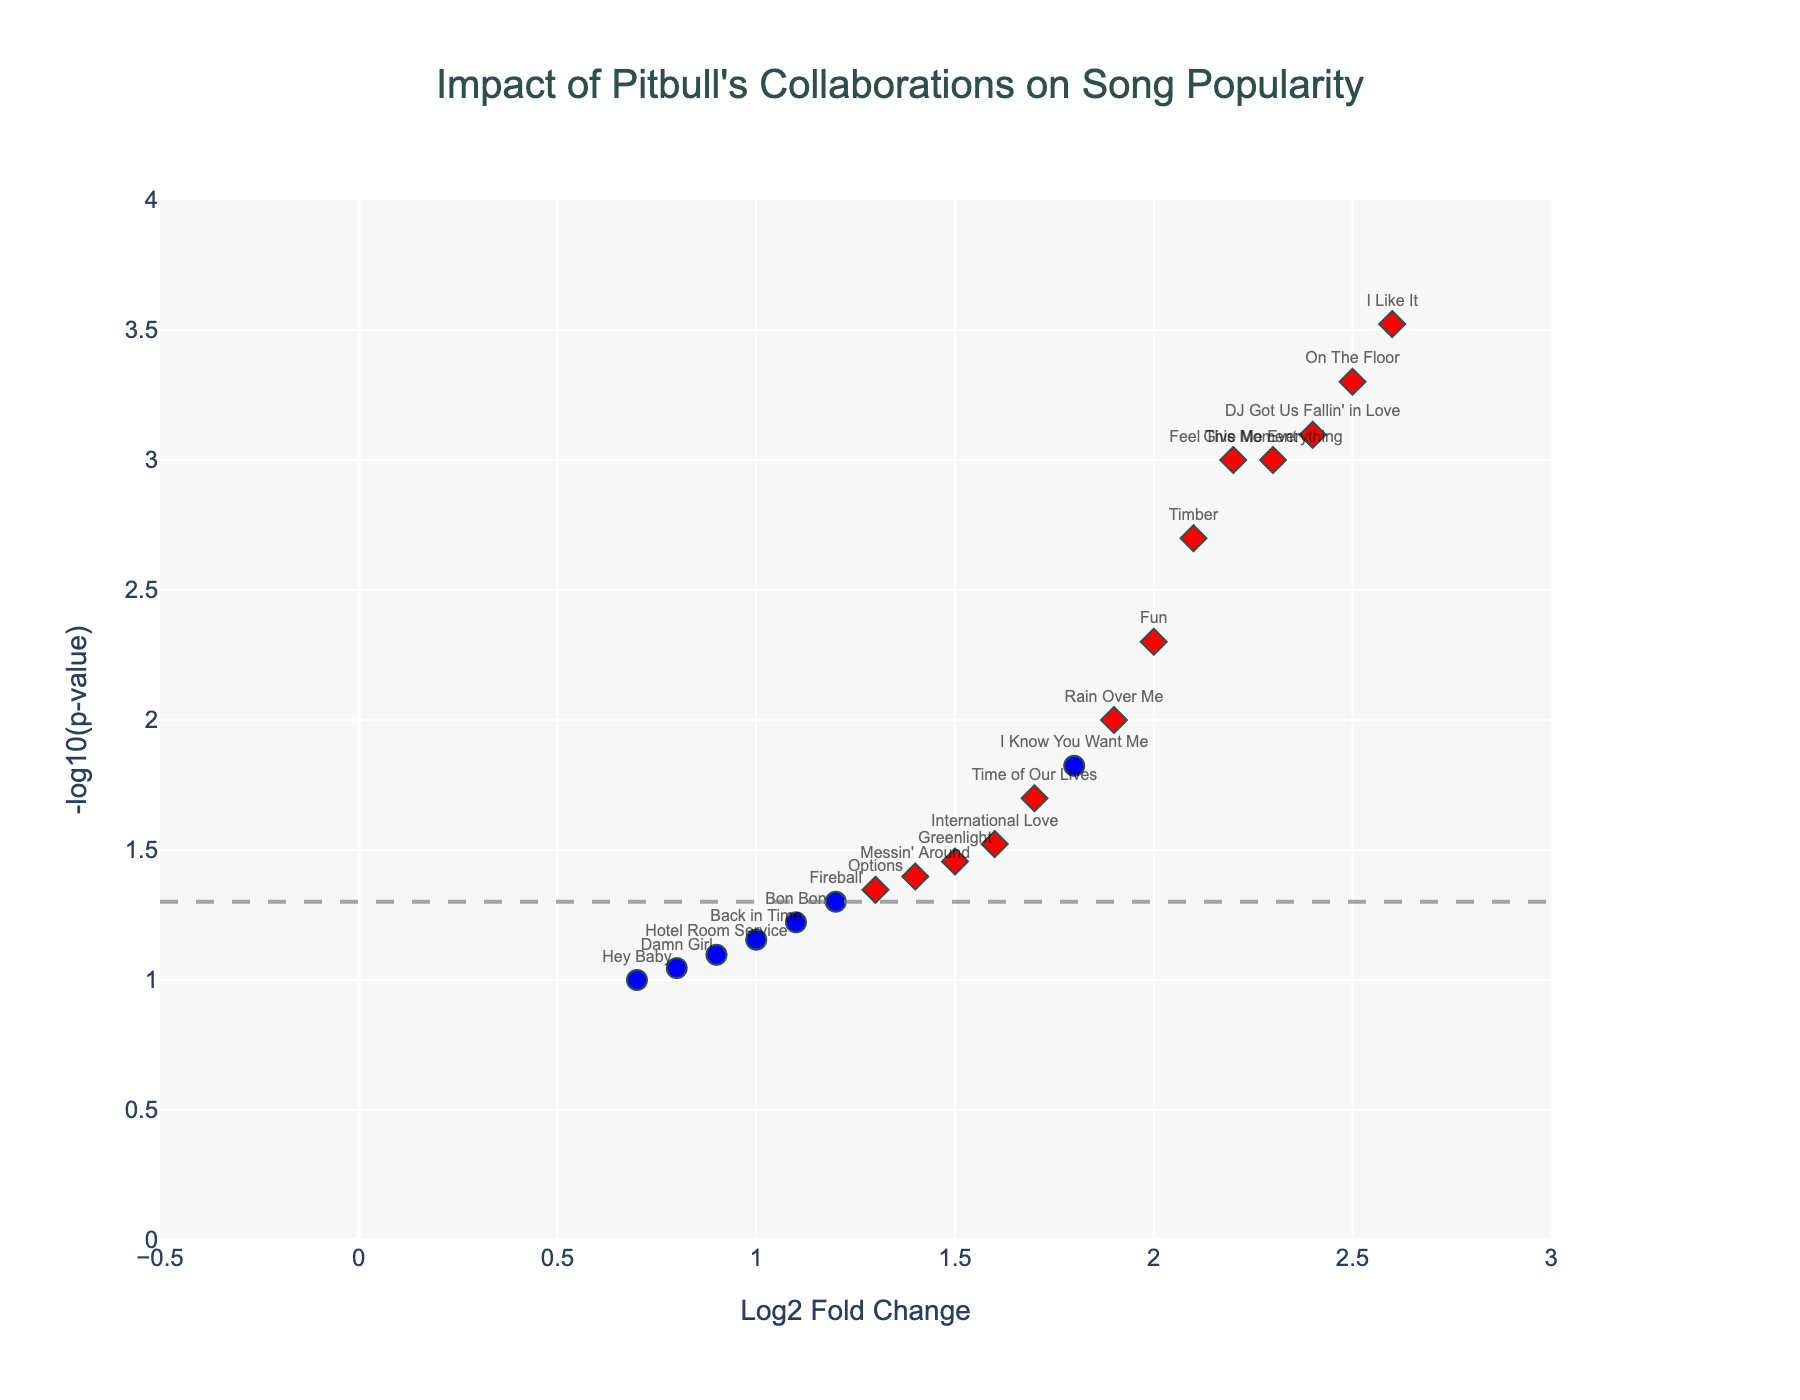what is the title of the figure? The title is located at the top center of the figure and provides an overall description of what the plot represents.
Answer: Impact of Pitbull's Collaborations on Song Popularity what does the x-axis represent? The x-axis label is located below the horizontal axis and indicates what the values on this axis represent.
Answer: Log2 Fold Change how are collaborations differentiated from solo tracks in the plot? Collaborations and solo tracks are differentiated by two distinct colors and symbols. Collaborations are marked in red diamonds, while solo tracks are marked in blue circles.
Answer: Red diamonds for collaborations, blue circles for solo tracks which song has the highest log2 fold change? Look at the data points along the x-axis and identify the song title that is farthest to the right.
Answer: I Like It how many songs have a p-value below 0.05? Identify the threshold line at -log10(0.05) on the y-axis and count all the data points above this line.
Answer: 14 what is the p-value threshold indicated by the horizontal dashed line? The horizontal dashed line represents the threshold for significance, which is labeled on the y-axis.
Answer: 0.05 which collaboration has the lowest p-value? Compare the y-axis values (height on the plot) of red diamonds and find the highest point.
Answer: I Like It are there more collaborations or solo tracks above the significance threshold? Count the number of red diamonds vs. blue circles above the horizontal dashed line at -log10(0.05).
Answer: More collaborations compare the popularity impact between “Fireball” and “Fun.”, which one is more significant? Check the y-axis values for both "Fireball" and "Fun" and compare their heights. "Fun" is higher on the y-axis, indicating a lower p-value and thus more significance.
Answer: Fun how many solo tracks do not pass the significance threshold? Count the number of blue circles below the horizontal dashed line at -log10(0.05).
Answer: 3 